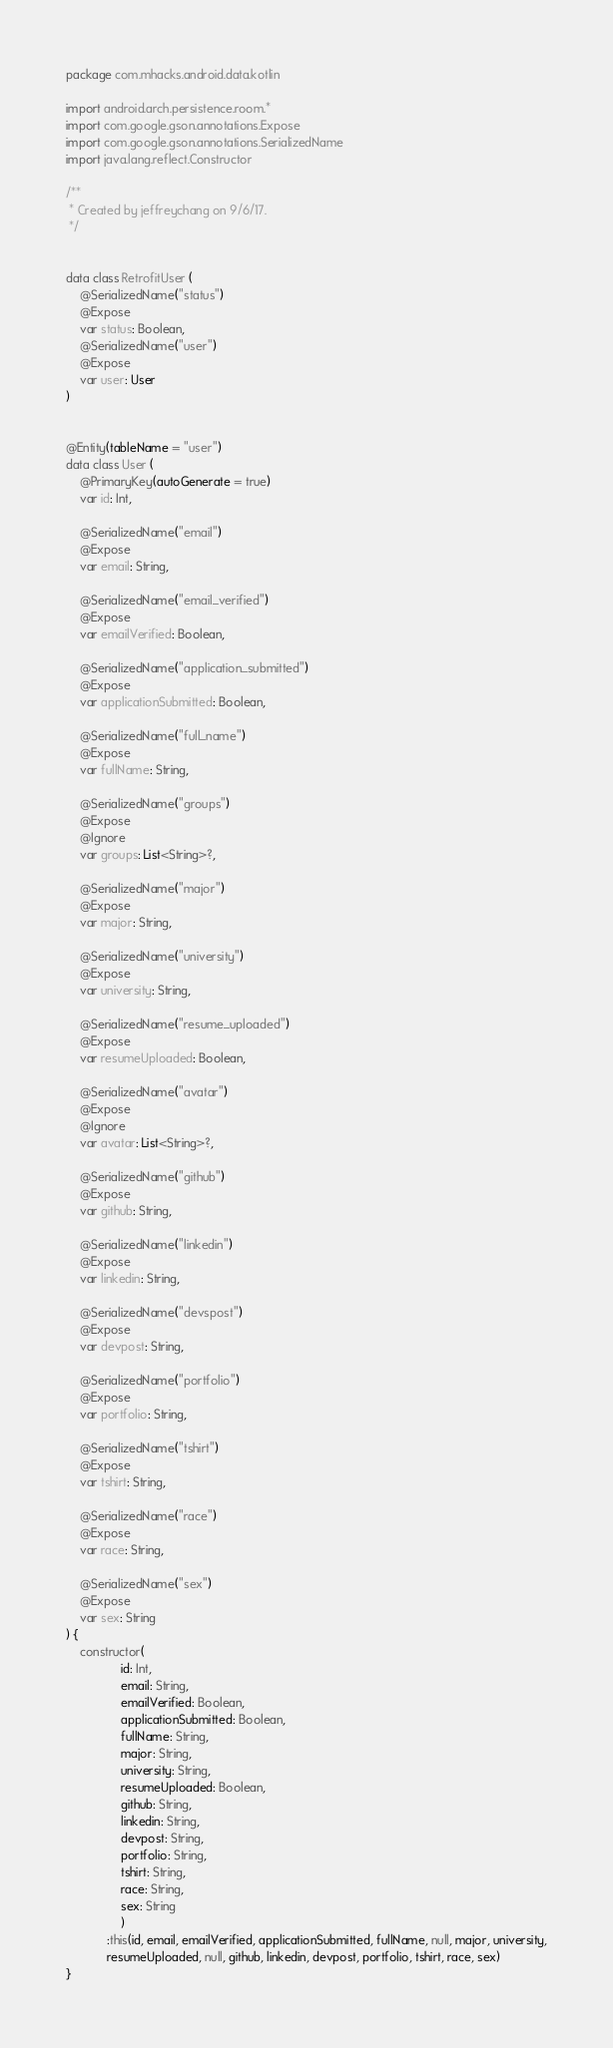Convert code to text. <code><loc_0><loc_0><loc_500><loc_500><_Kotlin_>package com.mhacks.android.data.kotlin

import android.arch.persistence.room.*
import com.google.gson.annotations.Expose
import com.google.gson.annotations.SerializedName
import java.lang.reflect.Constructor

/**
 * Created by jeffreychang on 9/6/17.
 */


data class RetrofitUser (
    @SerializedName("status")
    @Expose
    var status: Boolean,
    @SerializedName("user")
    @Expose
    var user: User
)


@Entity(tableName = "user")
data class User (
    @PrimaryKey(autoGenerate = true)
    var id: Int,

    @SerializedName("email")
    @Expose
    var email: String,

    @SerializedName("email_verified")
    @Expose
    var emailVerified: Boolean,

    @SerializedName("application_submitted")
    @Expose
    var applicationSubmitted: Boolean,

    @SerializedName("full_name")
    @Expose
    var fullName: String,

    @SerializedName("groups")
    @Expose
    @Ignore
    var groups: List<String>?,

    @SerializedName("major")
    @Expose
    var major: String,

    @SerializedName("university")
    @Expose
    var university: String,

    @SerializedName("resume_uploaded")
    @Expose
    var resumeUploaded: Boolean,

    @SerializedName("avatar")
    @Expose
    @Ignore
    var avatar: List<String>?,

    @SerializedName("github")
    @Expose
    var github: String,

    @SerializedName("linkedin")
    @Expose
    var linkedin: String,

    @SerializedName("devspost")
    @Expose
    var devpost: String,

    @SerializedName("portfolio")
    @Expose
    var portfolio: String,

    @SerializedName("tshirt")
    @Expose
    var tshirt: String,

    @SerializedName("race")
    @Expose
    var race: String,

    @SerializedName("sex")
    @Expose
    var sex: String
) {
    constructor(
                id: Int,
                email: String,
                emailVerified: Boolean,
                applicationSubmitted: Boolean,
                fullName: String,
                major: String,
                university: String,
                resumeUploaded: Boolean,
                github: String,
                linkedin: String,
                devpost: String,
                portfolio: String,
                tshirt: String,
                race: String,
                sex: String
                )
            :this(id, email, emailVerified, applicationSubmitted, fullName, null, major, university,
            resumeUploaded, null, github, linkedin, devpost, portfolio, tshirt, race, sex)
}
</code> 